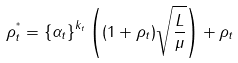Convert formula to latex. <formula><loc_0><loc_0><loc_500><loc_500>\rho _ { t } ^ { ^ { * } } = \left \{ \alpha _ { t } \right \} ^ { k _ { t } } \left ( ( 1 + \rho _ { t } ) \sqrt { \frac { L } { \mu } } \right ) + \rho _ { t }</formula> 